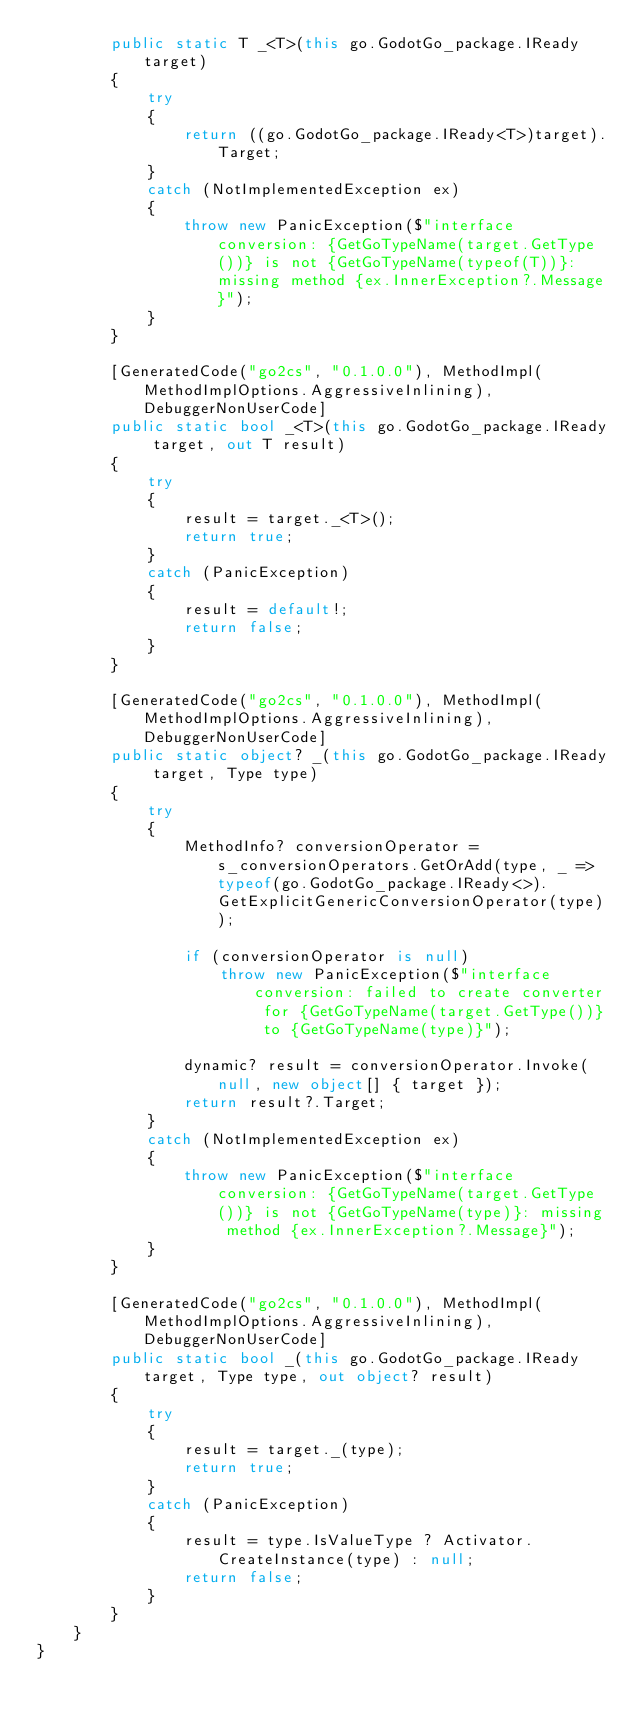Convert code to text. <code><loc_0><loc_0><loc_500><loc_500><_C#_>        public static T _<T>(this go.GodotGo_package.IReady target)
        {
            try
            {
                return ((go.GodotGo_package.IReady<T>)target).Target;
            }
            catch (NotImplementedException ex)
            {
                throw new PanicException($"interface conversion: {GetGoTypeName(target.GetType())} is not {GetGoTypeName(typeof(T))}: missing method {ex.InnerException?.Message}");
            }
        }

        [GeneratedCode("go2cs", "0.1.0.0"), MethodImpl(MethodImplOptions.AggressiveInlining), DebuggerNonUserCode]
        public static bool _<T>(this go.GodotGo_package.IReady target, out T result)
        {
            try
            {
                result = target._<T>();
                return true;
            }
            catch (PanicException)
            {
                result = default!;
                return false;
            }
        }

        [GeneratedCode("go2cs", "0.1.0.0"), MethodImpl(MethodImplOptions.AggressiveInlining), DebuggerNonUserCode]
        public static object? _(this go.GodotGo_package.IReady target, Type type)
        {
            try
            {
                MethodInfo? conversionOperator = s_conversionOperators.GetOrAdd(type, _ => typeof(go.GodotGo_package.IReady<>).GetExplicitGenericConversionOperator(type));

                if (conversionOperator is null)
                    throw new PanicException($"interface conversion: failed to create converter for {GetGoTypeName(target.GetType())} to {GetGoTypeName(type)}");

                dynamic? result = conversionOperator.Invoke(null, new object[] { target });
                return result?.Target;
            }
            catch (NotImplementedException ex)
            {
                throw new PanicException($"interface conversion: {GetGoTypeName(target.GetType())} is not {GetGoTypeName(type)}: missing method {ex.InnerException?.Message}");
            }
        }

        [GeneratedCode("go2cs", "0.1.0.0"), MethodImpl(MethodImplOptions.AggressiveInlining), DebuggerNonUserCode]
        public static bool _(this go.GodotGo_package.IReady target, Type type, out object? result)
        {
            try
            {
                result = target._(type);
                return true;
            }
            catch (PanicException)
            {
                result = type.IsValueType ? Activator.CreateInstance(type) : null;
                return false;
            }
        }
    }
}</code> 